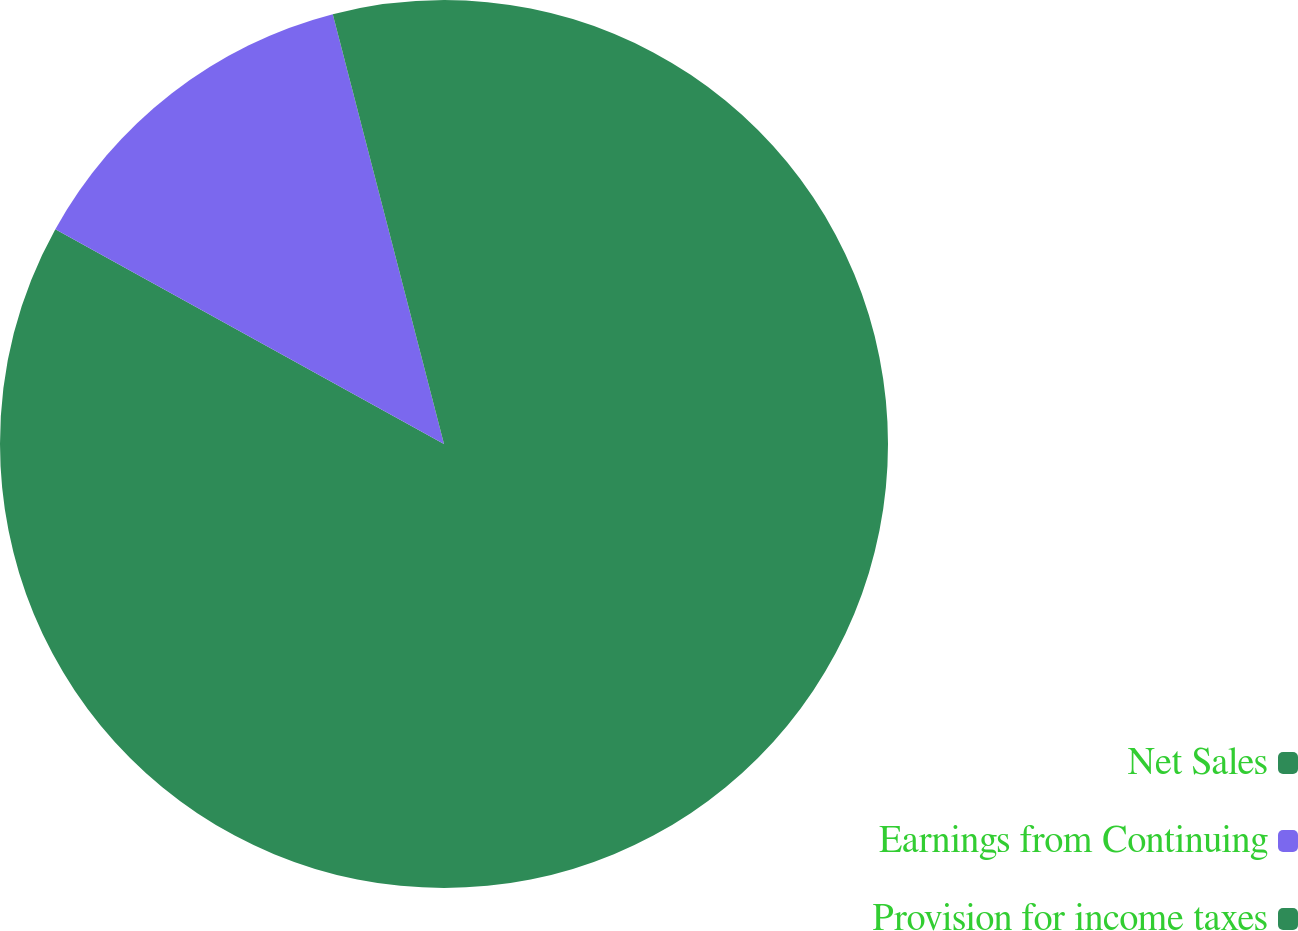<chart> <loc_0><loc_0><loc_500><loc_500><pie_chart><fcel>Net Sales<fcel>Earnings from Continuing<fcel>Provision for income taxes<nl><fcel>83.04%<fcel>12.94%<fcel>4.03%<nl></chart> 